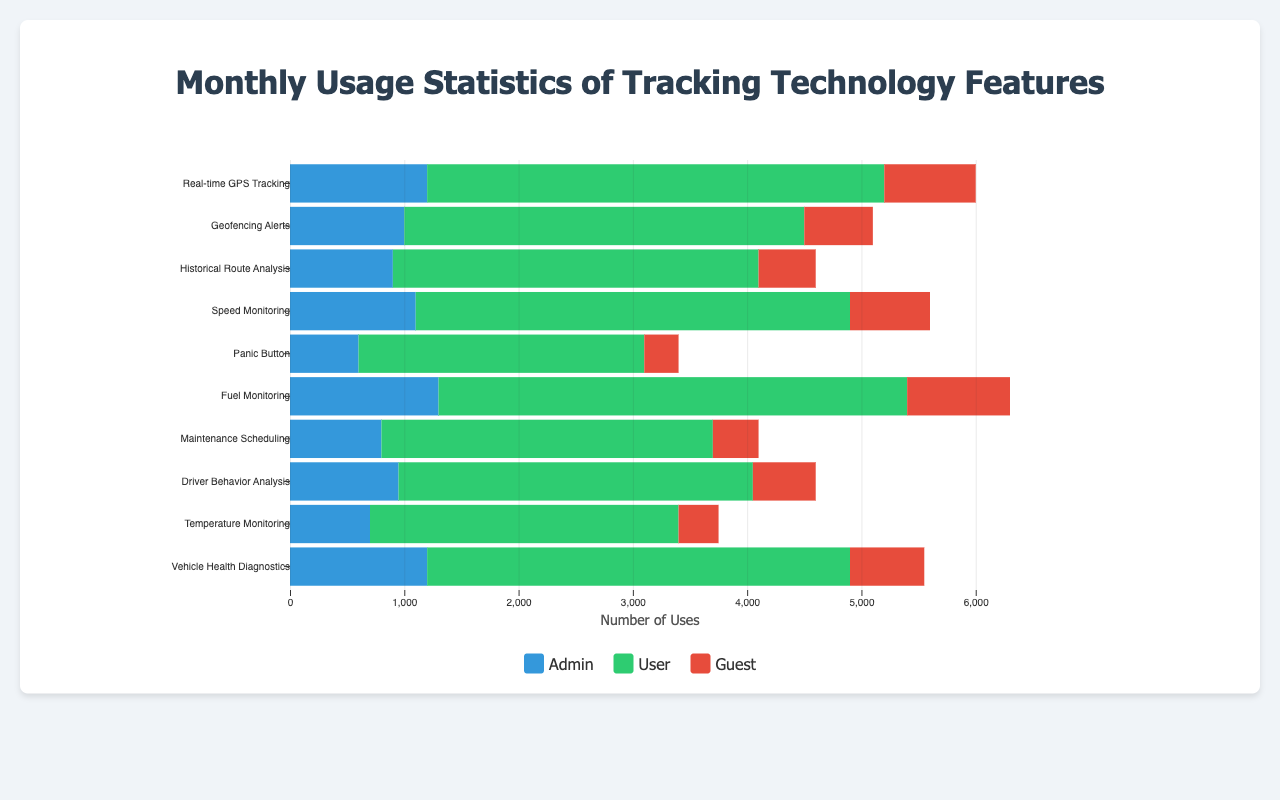Which feature has the highest usage for admins? By comparing the heights of the blue sections (admin) of each bar, we see that "Fuel Monitoring" has the largest height.
Answer: Fuel Monitoring Which user role uses the Speed Monitoring feature the most? Looking at the Speed Monitoring bar, the green section (user) is the largest.
Answer: User What's the total usage for the Vehicle Health Diagnostics feature across all roles? Sum the numbers: 1200 (admin) + 3700 (user) + 650 (guest). Total is 5550.
Answer: 5550 What is the feature with the least guest usage? For guest usage, the red sections, the smallest is "Panic Button" with 300.
Answer: Panic Button How does guest usage of Real-time GPS Tracking compare with admin usage of the same feature? The guest usage is 800, while the admin usage is 1200. Therefore, guests use it less than admins.
Answer: Less than Which role has the most varied usage across all features? By examining the variation in the heights of the colored sections: Users have the most variation as their usage spans the largest range from the smallest to the largest bar segments.
Answer: User What is the combined user and guest usage for the Geofencing Alerts feature? Sum the user and guest usage: 3500 (user) + 600 (guest). Total is 4100.
Answer: 4100 What percentage of the total Real-time GPS Tracking usage is attributed to the guest role? Calculate total usage for Real-time GPS Tracking (1200 admin + 4000 user + 800 guest = 6000). Guest usage is 800, so the percentage is (800/6000) * 100 = 13.3%.
Answer: 13.3% Which feature has approximately equal usage by admins and guests? The bar sections are visibly similar for "Historical Route Analysis", with 900 (admin) and 500 (guest).
Answer: Historical Route Analysis How many more times is the Fuel Monitoring feature used by users compared to guests? User usage for Fuel Monitoring is 4100, guest usage is 900, the ratio is 4100 / 900 ≈ 4.56. So, it is approximately 4.56 times.
Answer: 4.56 